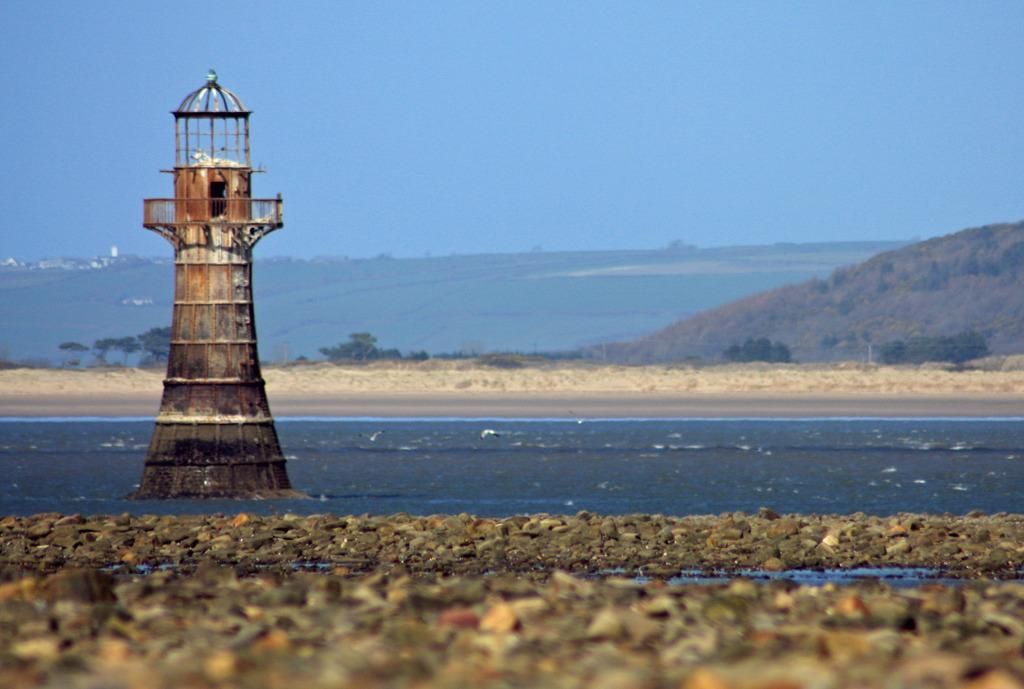What structure is the main focus of the image? There is a tower in the image. What can be seen at the base of the tower? There are stones at the bottom of the image. What natural element is visible in the image? There is water visible in the image. What type of landscape can be seen in the background of the image? There are mountains and trees in the background of the image. What is visible in the sky in the image? The sky is visible in the background of the image. Can you see a feather floating in the water in the image? There is no feather visible in the water in the image. Is there a squirrel climbing the tower in the image? There is no squirrel present in the image. 